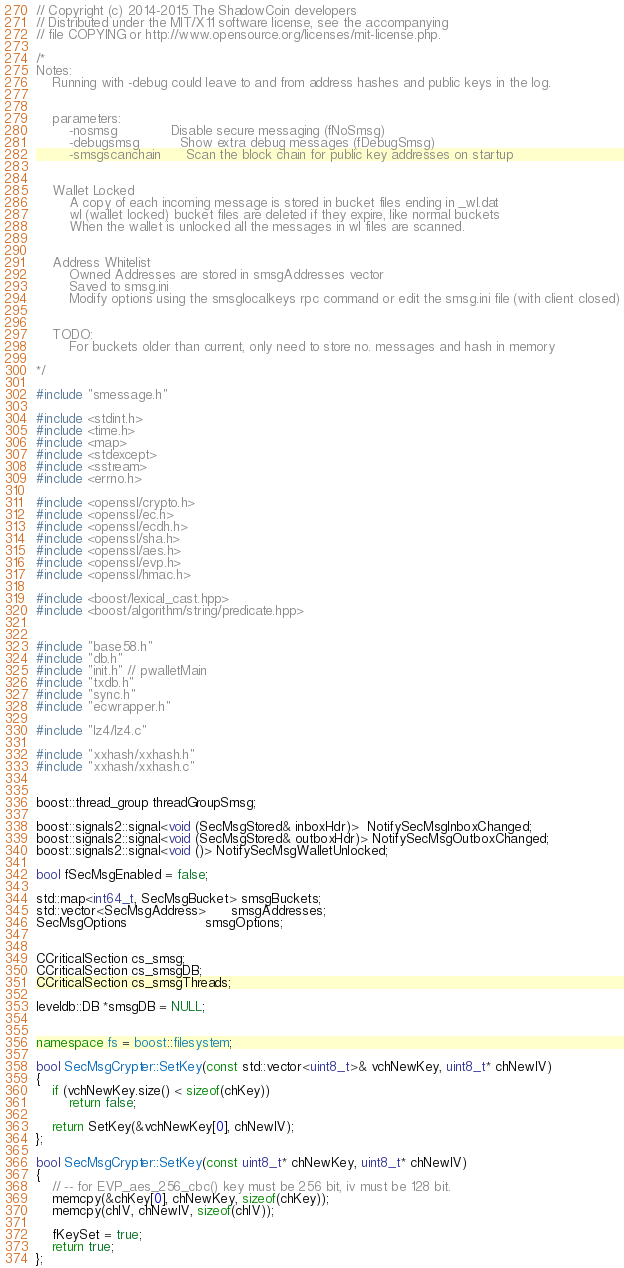Convert code to text. <code><loc_0><loc_0><loc_500><loc_500><_C++_>// Copyright (c) 2014-2015 The ShadowCoin developers
// Distributed under the MIT/X11 software license, see the accompanying
// file COPYING or http://www.opensource.org/licenses/mit-license.php.

/*
Notes:
    Running with -debug could leave to and from address hashes and public keys in the log.


    parameters:
        -nosmsg             Disable secure messaging (fNoSmsg)
        -debugsmsg          Show extra debug messages (fDebugSmsg)
        -smsgscanchain      Scan the block chain for public key addresses on startup


    Wallet Locked
        A copy of each incoming message is stored in bucket files ending in _wl.dat
        wl (wallet locked) bucket files are deleted if they expire, like normal buckets
        When the wallet is unlocked all the messages in wl files are scanned.


    Address Whitelist
        Owned Addresses are stored in smsgAddresses vector
        Saved to smsg.ini
        Modify options using the smsglocalkeys rpc command or edit the smsg.ini file (with client closed)
    
    
    TODO:
        For buckets older than current, only need to store no. messages and hash in memory

*/

#include "smessage.h"

#include <stdint.h>
#include <time.h>
#include <map>
#include <stdexcept>
#include <sstream>
#include <errno.h>

#include <openssl/crypto.h>
#include <openssl/ec.h>
#include <openssl/ecdh.h>
#include <openssl/sha.h>
#include <openssl/aes.h>
#include <openssl/evp.h>
#include <openssl/hmac.h>

#include <boost/lexical_cast.hpp>
#include <boost/algorithm/string/predicate.hpp>


#include "base58.h"
#include "db.h"
#include "init.h" // pwalletMain
#include "txdb.h"
#include "sync.h"
#include "ecwrapper.h"

#include "lz4/lz4.c"

#include "xxhash/xxhash.h"
#include "xxhash/xxhash.c"


boost::thread_group threadGroupSmsg;

boost::signals2::signal<void (SecMsgStored& inboxHdr)>  NotifySecMsgInboxChanged;
boost::signals2::signal<void (SecMsgStored& outboxHdr)> NotifySecMsgOutboxChanged;
boost::signals2::signal<void ()> NotifySecMsgWalletUnlocked;

bool fSecMsgEnabled = false;

std::map<int64_t, SecMsgBucket> smsgBuckets;
std::vector<SecMsgAddress>      smsgAddresses;
SecMsgOptions                   smsgOptions;


CCriticalSection cs_smsg;
CCriticalSection cs_smsgDB;
CCriticalSection cs_smsgThreads;

leveldb::DB *smsgDB = NULL;


namespace fs = boost::filesystem;

bool SecMsgCrypter::SetKey(const std::vector<uint8_t>& vchNewKey, uint8_t* chNewIV)
{
    if (vchNewKey.size() < sizeof(chKey))
        return false;

    return SetKey(&vchNewKey[0], chNewIV);
};

bool SecMsgCrypter::SetKey(const uint8_t* chNewKey, uint8_t* chNewIV)
{
    // -- for EVP_aes_256_cbc() key must be 256 bit, iv must be 128 bit.
    memcpy(&chKey[0], chNewKey, sizeof(chKey));
    memcpy(chIV, chNewIV, sizeof(chIV));

    fKeySet = true;
    return true;
};
</code> 